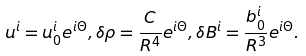<formula> <loc_0><loc_0><loc_500><loc_500>u ^ { i } = u _ { 0 } ^ { i } e ^ { i \Theta } , \delta \rho = \frac { C } { R ^ { 4 } } e ^ { i \Theta } , \delta B ^ { i } = \frac { b _ { 0 } ^ { i } } { R ^ { 3 } } e ^ { i \Theta } .</formula> 